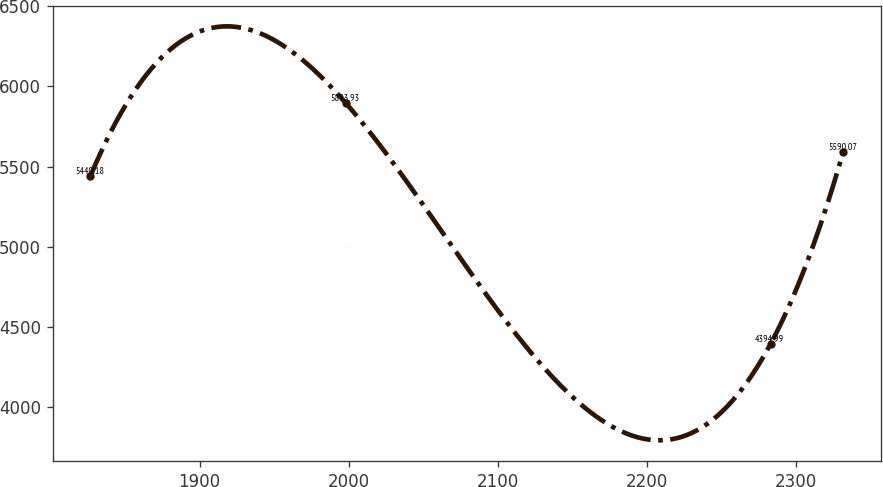Convert chart. <chart><loc_0><loc_0><loc_500><loc_500><line_chart><ecel><fcel>Unnamed: 1<nl><fcel>1826.82<fcel>5440.18<nl><fcel>1998.22<fcel>5893.93<nl><fcel>2282.93<fcel>4394.99<nl><fcel>2331.63<fcel>5590.07<nl></chart> 